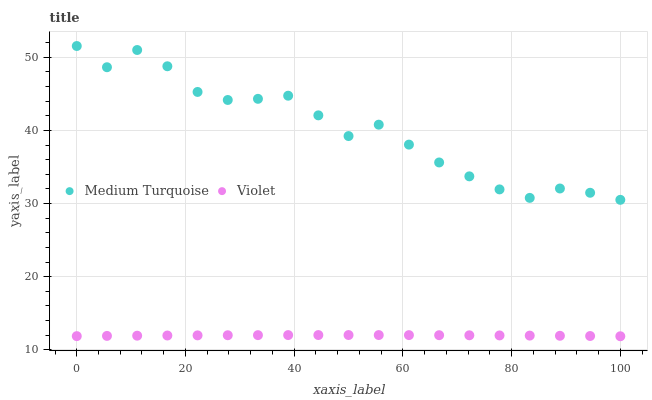Does Violet have the minimum area under the curve?
Answer yes or no. Yes. Does Medium Turquoise have the maximum area under the curve?
Answer yes or no. Yes. Does Violet have the maximum area under the curve?
Answer yes or no. No. Is Violet the smoothest?
Answer yes or no. Yes. Is Medium Turquoise the roughest?
Answer yes or no. Yes. Is Violet the roughest?
Answer yes or no. No. Does Violet have the lowest value?
Answer yes or no. Yes. Does Medium Turquoise have the highest value?
Answer yes or no. Yes. Does Violet have the highest value?
Answer yes or no. No. Is Violet less than Medium Turquoise?
Answer yes or no. Yes. Is Medium Turquoise greater than Violet?
Answer yes or no. Yes. Does Violet intersect Medium Turquoise?
Answer yes or no. No. 